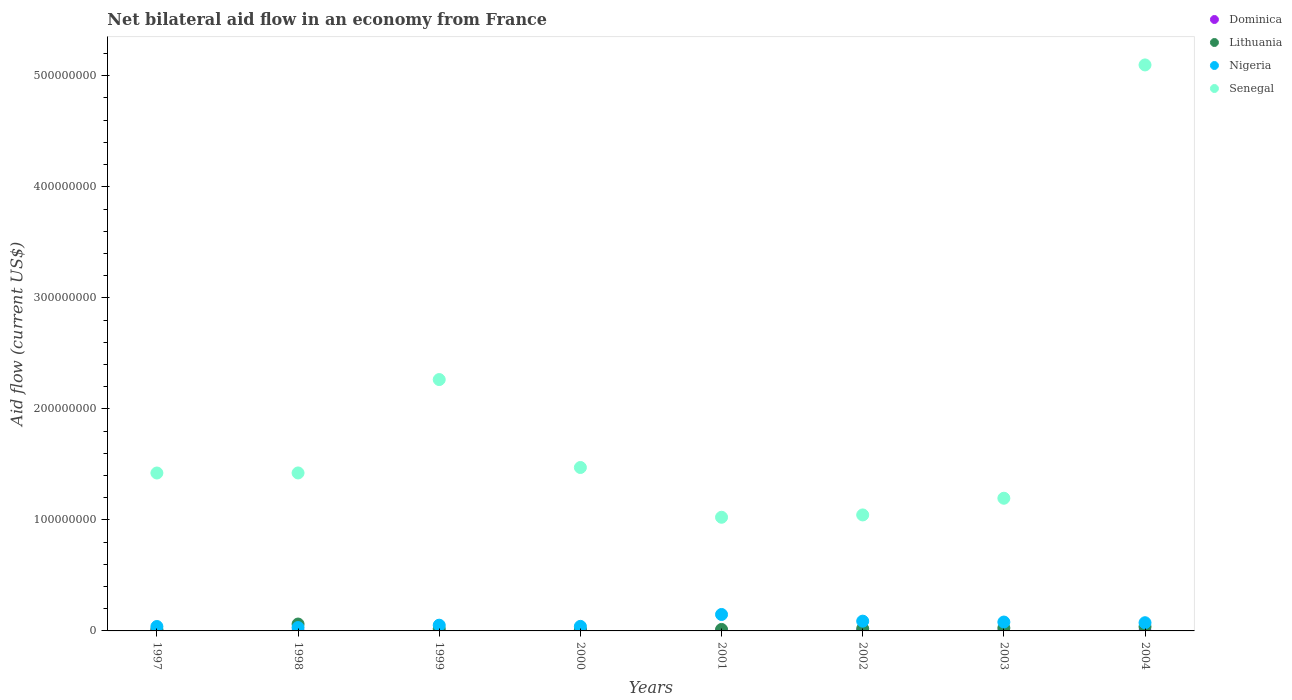What is the net bilateral aid flow in Nigeria in 1997?
Ensure brevity in your answer.  3.98e+06. Across all years, what is the maximum net bilateral aid flow in Nigeria?
Offer a very short reply. 1.48e+07. Across all years, what is the minimum net bilateral aid flow in Senegal?
Your response must be concise. 1.02e+08. In which year was the net bilateral aid flow in Senegal maximum?
Keep it short and to the point. 2004. What is the total net bilateral aid flow in Nigeria in the graph?
Ensure brevity in your answer.  5.52e+07. What is the difference between the net bilateral aid flow in Nigeria in 1999 and that in 2003?
Offer a terse response. -2.83e+06. What is the difference between the net bilateral aid flow in Nigeria in 2004 and the net bilateral aid flow in Senegal in 2002?
Give a very brief answer. -9.71e+07. What is the average net bilateral aid flow in Dominica per year?
Provide a succinct answer. 2.50e+04. In the year 2002, what is the difference between the net bilateral aid flow in Senegal and net bilateral aid flow in Nigeria?
Keep it short and to the point. 9.57e+07. In how many years, is the net bilateral aid flow in Dominica greater than 80000000 US$?
Make the answer very short. 0. What is the ratio of the net bilateral aid flow in Nigeria in 2002 to that in 2004?
Your answer should be very brief. 1.19. What is the difference between the highest and the second highest net bilateral aid flow in Senegal?
Make the answer very short. 2.83e+08. What is the difference between the highest and the lowest net bilateral aid flow in Senegal?
Your answer should be compact. 4.07e+08. In how many years, is the net bilateral aid flow in Senegal greater than the average net bilateral aid flow in Senegal taken over all years?
Provide a short and direct response. 2. Is the sum of the net bilateral aid flow in Lithuania in 2000 and 2001 greater than the maximum net bilateral aid flow in Senegal across all years?
Offer a very short reply. No. Does the net bilateral aid flow in Lithuania monotonically increase over the years?
Give a very brief answer. No. Is the net bilateral aid flow in Nigeria strictly greater than the net bilateral aid flow in Senegal over the years?
Your answer should be compact. No. Is the net bilateral aid flow in Senegal strictly less than the net bilateral aid flow in Nigeria over the years?
Provide a succinct answer. No. How many dotlines are there?
Keep it short and to the point. 4. Are the values on the major ticks of Y-axis written in scientific E-notation?
Your response must be concise. No. Does the graph contain grids?
Give a very brief answer. No. Where does the legend appear in the graph?
Provide a succinct answer. Top right. What is the title of the graph?
Offer a very short reply. Net bilateral aid flow in an economy from France. Does "Low income" appear as one of the legend labels in the graph?
Provide a succinct answer. No. What is the Aid flow (current US$) of Dominica in 1997?
Your answer should be very brief. 1.50e+05. What is the Aid flow (current US$) of Lithuania in 1997?
Your answer should be very brief. 1.29e+06. What is the Aid flow (current US$) in Nigeria in 1997?
Keep it short and to the point. 3.98e+06. What is the Aid flow (current US$) in Senegal in 1997?
Provide a succinct answer. 1.42e+08. What is the Aid flow (current US$) in Lithuania in 1998?
Make the answer very short. 6.20e+06. What is the Aid flow (current US$) of Nigeria in 1998?
Provide a short and direct response. 3.04e+06. What is the Aid flow (current US$) of Senegal in 1998?
Offer a terse response. 1.42e+08. What is the Aid flow (current US$) of Dominica in 1999?
Offer a terse response. 0. What is the Aid flow (current US$) in Lithuania in 1999?
Your response must be concise. 1.85e+06. What is the Aid flow (current US$) of Nigeria in 1999?
Your response must be concise. 5.16e+06. What is the Aid flow (current US$) in Senegal in 1999?
Keep it short and to the point. 2.26e+08. What is the Aid flow (current US$) in Lithuania in 2000?
Your response must be concise. 1.45e+06. What is the Aid flow (current US$) of Nigeria in 2000?
Keep it short and to the point. 4.10e+06. What is the Aid flow (current US$) in Senegal in 2000?
Make the answer very short. 1.47e+08. What is the Aid flow (current US$) of Dominica in 2001?
Offer a very short reply. 0. What is the Aid flow (current US$) in Lithuania in 2001?
Your answer should be compact. 1.34e+06. What is the Aid flow (current US$) of Nigeria in 2001?
Provide a short and direct response. 1.48e+07. What is the Aid flow (current US$) of Senegal in 2001?
Offer a very short reply. 1.02e+08. What is the Aid flow (current US$) in Lithuania in 2002?
Provide a succinct answer. 2.03e+06. What is the Aid flow (current US$) in Nigeria in 2002?
Provide a succinct answer. 8.79e+06. What is the Aid flow (current US$) in Senegal in 2002?
Provide a succinct answer. 1.04e+08. What is the Aid flow (current US$) of Dominica in 2003?
Give a very brief answer. 0. What is the Aid flow (current US$) of Lithuania in 2003?
Offer a terse response. 2.67e+06. What is the Aid flow (current US$) in Nigeria in 2003?
Provide a succinct answer. 7.99e+06. What is the Aid flow (current US$) in Senegal in 2003?
Make the answer very short. 1.20e+08. What is the Aid flow (current US$) in Dominica in 2004?
Offer a terse response. 0. What is the Aid flow (current US$) of Lithuania in 2004?
Your answer should be compact. 3.74e+06. What is the Aid flow (current US$) in Nigeria in 2004?
Offer a terse response. 7.38e+06. What is the Aid flow (current US$) in Senegal in 2004?
Ensure brevity in your answer.  5.10e+08. Across all years, what is the maximum Aid flow (current US$) in Dominica?
Offer a terse response. 1.50e+05. Across all years, what is the maximum Aid flow (current US$) of Lithuania?
Ensure brevity in your answer.  6.20e+06. Across all years, what is the maximum Aid flow (current US$) in Nigeria?
Keep it short and to the point. 1.48e+07. Across all years, what is the maximum Aid flow (current US$) of Senegal?
Offer a terse response. 5.10e+08. Across all years, what is the minimum Aid flow (current US$) in Dominica?
Keep it short and to the point. 0. Across all years, what is the minimum Aid flow (current US$) in Lithuania?
Provide a short and direct response. 1.29e+06. Across all years, what is the minimum Aid flow (current US$) of Nigeria?
Keep it short and to the point. 3.04e+06. Across all years, what is the minimum Aid flow (current US$) of Senegal?
Keep it short and to the point. 1.02e+08. What is the total Aid flow (current US$) of Lithuania in the graph?
Your response must be concise. 2.06e+07. What is the total Aid flow (current US$) of Nigeria in the graph?
Your response must be concise. 5.52e+07. What is the total Aid flow (current US$) in Senegal in the graph?
Offer a very short reply. 1.49e+09. What is the difference between the Aid flow (current US$) of Lithuania in 1997 and that in 1998?
Offer a very short reply. -4.91e+06. What is the difference between the Aid flow (current US$) in Nigeria in 1997 and that in 1998?
Your answer should be compact. 9.40e+05. What is the difference between the Aid flow (current US$) in Senegal in 1997 and that in 1998?
Offer a very short reply. -5.00e+04. What is the difference between the Aid flow (current US$) of Lithuania in 1997 and that in 1999?
Your answer should be compact. -5.60e+05. What is the difference between the Aid flow (current US$) in Nigeria in 1997 and that in 1999?
Make the answer very short. -1.18e+06. What is the difference between the Aid flow (current US$) in Senegal in 1997 and that in 1999?
Provide a short and direct response. -8.42e+07. What is the difference between the Aid flow (current US$) of Lithuania in 1997 and that in 2000?
Give a very brief answer. -1.60e+05. What is the difference between the Aid flow (current US$) of Nigeria in 1997 and that in 2000?
Your answer should be compact. -1.20e+05. What is the difference between the Aid flow (current US$) in Senegal in 1997 and that in 2000?
Provide a short and direct response. -4.96e+06. What is the difference between the Aid flow (current US$) in Nigeria in 1997 and that in 2001?
Your answer should be compact. -1.08e+07. What is the difference between the Aid flow (current US$) of Senegal in 1997 and that in 2001?
Make the answer very short. 3.99e+07. What is the difference between the Aid flow (current US$) of Lithuania in 1997 and that in 2002?
Offer a very short reply. -7.40e+05. What is the difference between the Aid flow (current US$) in Nigeria in 1997 and that in 2002?
Your answer should be compact. -4.81e+06. What is the difference between the Aid flow (current US$) in Senegal in 1997 and that in 2002?
Your response must be concise. 3.78e+07. What is the difference between the Aid flow (current US$) of Lithuania in 1997 and that in 2003?
Ensure brevity in your answer.  -1.38e+06. What is the difference between the Aid flow (current US$) of Nigeria in 1997 and that in 2003?
Ensure brevity in your answer.  -4.01e+06. What is the difference between the Aid flow (current US$) in Senegal in 1997 and that in 2003?
Offer a very short reply. 2.27e+07. What is the difference between the Aid flow (current US$) of Lithuania in 1997 and that in 2004?
Give a very brief answer. -2.45e+06. What is the difference between the Aid flow (current US$) in Nigeria in 1997 and that in 2004?
Your answer should be very brief. -3.40e+06. What is the difference between the Aid flow (current US$) in Senegal in 1997 and that in 2004?
Provide a succinct answer. -3.68e+08. What is the difference between the Aid flow (current US$) of Lithuania in 1998 and that in 1999?
Keep it short and to the point. 4.35e+06. What is the difference between the Aid flow (current US$) of Nigeria in 1998 and that in 1999?
Provide a succinct answer. -2.12e+06. What is the difference between the Aid flow (current US$) in Senegal in 1998 and that in 1999?
Your response must be concise. -8.41e+07. What is the difference between the Aid flow (current US$) in Lithuania in 1998 and that in 2000?
Your response must be concise. 4.75e+06. What is the difference between the Aid flow (current US$) in Nigeria in 1998 and that in 2000?
Offer a very short reply. -1.06e+06. What is the difference between the Aid flow (current US$) of Senegal in 1998 and that in 2000?
Provide a short and direct response. -4.91e+06. What is the difference between the Aid flow (current US$) in Lithuania in 1998 and that in 2001?
Ensure brevity in your answer.  4.86e+06. What is the difference between the Aid flow (current US$) of Nigeria in 1998 and that in 2001?
Your response must be concise. -1.18e+07. What is the difference between the Aid flow (current US$) in Senegal in 1998 and that in 2001?
Give a very brief answer. 3.99e+07. What is the difference between the Aid flow (current US$) of Lithuania in 1998 and that in 2002?
Make the answer very short. 4.17e+06. What is the difference between the Aid flow (current US$) of Nigeria in 1998 and that in 2002?
Your answer should be compact. -5.75e+06. What is the difference between the Aid flow (current US$) of Senegal in 1998 and that in 2002?
Your answer should be very brief. 3.78e+07. What is the difference between the Aid flow (current US$) of Lithuania in 1998 and that in 2003?
Keep it short and to the point. 3.53e+06. What is the difference between the Aid flow (current US$) of Nigeria in 1998 and that in 2003?
Offer a terse response. -4.95e+06. What is the difference between the Aid flow (current US$) in Senegal in 1998 and that in 2003?
Offer a terse response. 2.28e+07. What is the difference between the Aid flow (current US$) in Lithuania in 1998 and that in 2004?
Provide a short and direct response. 2.46e+06. What is the difference between the Aid flow (current US$) of Nigeria in 1998 and that in 2004?
Offer a terse response. -4.34e+06. What is the difference between the Aid flow (current US$) of Senegal in 1998 and that in 2004?
Your response must be concise. -3.67e+08. What is the difference between the Aid flow (current US$) of Nigeria in 1999 and that in 2000?
Give a very brief answer. 1.06e+06. What is the difference between the Aid flow (current US$) of Senegal in 1999 and that in 2000?
Your answer should be compact. 7.92e+07. What is the difference between the Aid flow (current US$) in Lithuania in 1999 and that in 2001?
Keep it short and to the point. 5.10e+05. What is the difference between the Aid flow (current US$) of Nigeria in 1999 and that in 2001?
Make the answer very short. -9.65e+06. What is the difference between the Aid flow (current US$) in Senegal in 1999 and that in 2001?
Your answer should be compact. 1.24e+08. What is the difference between the Aid flow (current US$) in Lithuania in 1999 and that in 2002?
Ensure brevity in your answer.  -1.80e+05. What is the difference between the Aid flow (current US$) in Nigeria in 1999 and that in 2002?
Your answer should be compact. -3.63e+06. What is the difference between the Aid flow (current US$) in Senegal in 1999 and that in 2002?
Provide a short and direct response. 1.22e+08. What is the difference between the Aid flow (current US$) in Lithuania in 1999 and that in 2003?
Offer a terse response. -8.20e+05. What is the difference between the Aid flow (current US$) in Nigeria in 1999 and that in 2003?
Keep it short and to the point. -2.83e+06. What is the difference between the Aid flow (current US$) of Senegal in 1999 and that in 2003?
Your answer should be very brief. 1.07e+08. What is the difference between the Aid flow (current US$) of Lithuania in 1999 and that in 2004?
Offer a terse response. -1.89e+06. What is the difference between the Aid flow (current US$) in Nigeria in 1999 and that in 2004?
Your answer should be very brief. -2.22e+06. What is the difference between the Aid flow (current US$) of Senegal in 1999 and that in 2004?
Your answer should be very brief. -2.83e+08. What is the difference between the Aid flow (current US$) in Lithuania in 2000 and that in 2001?
Keep it short and to the point. 1.10e+05. What is the difference between the Aid flow (current US$) of Nigeria in 2000 and that in 2001?
Your response must be concise. -1.07e+07. What is the difference between the Aid flow (current US$) of Senegal in 2000 and that in 2001?
Ensure brevity in your answer.  4.48e+07. What is the difference between the Aid flow (current US$) of Lithuania in 2000 and that in 2002?
Provide a short and direct response. -5.80e+05. What is the difference between the Aid flow (current US$) in Nigeria in 2000 and that in 2002?
Give a very brief answer. -4.69e+06. What is the difference between the Aid flow (current US$) of Senegal in 2000 and that in 2002?
Your response must be concise. 4.27e+07. What is the difference between the Aid flow (current US$) in Lithuania in 2000 and that in 2003?
Give a very brief answer. -1.22e+06. What is the difference between the Aid flow (current US$) of Nigeria in 2000 and that in 2003?
Your answer should be very brief. -3.89e+06. What is the difference between the Aid flow (current US$) of Senegal in 2000 and that in 2003?
Keep it short and to the point. 2.77e+07. What is the difference between the Aid flow (current US$) of Lithuania in 2000 and that in 2004?
Your answer should be very brief. -2.29e+06. What is the difference between the Aid flow (current US$) of Nigeria in 2000 and that in 2004?
Provide a short and direct response. -3.28e+06. What is the difference between the Aid flow (current US$) of Senegal in 2000 and that in 2004?
Your answer should be compact. -3.63e+08. What is the difference between the Aid flow (current US$) in Lithuania in 2001 and that in 2002?
Offer a terse response. -6.90e+05. What is the difference between the Aid flow (current US$) of Nigeria in 2001 and that in 2002?
Give a very brief answer. 6.02e+06. What is the difference between the Aid flow (current US$) in Senegal in 2001 and that in 2002?
Provide a succinct answer. -2.10e+06. What is the difference between the Aid flow (current US$) of Lithuania in 2001 and that in 2003?
Keep it short and to the point. -1.33e+06. What is the difference between the Aid flow (current US$) of Nigeria in 2001 and that in 2003?
Make the answer very short. 6.82e+06. What is the difference between the Aid flow (current US$) in Senegal in 2001 and that in 2003?
Offer a very short reply. -1.71e+07. What is the difference between the Aid flow (current US$) in Lithuania in 2001 and that in 2004?
Your answer should be very brief. -2.40e+06. What is the difference between the Aid flow (current US$) of Nigeria in 2001 and that in 2004?
Your answer should be compact. 7.43e+06. What is the difference between the Aid flow (current US$) of Senegal in 2001 and that in 2004?
Provide a succinct answer. -4.07e+08. What is the difference between the Aid flow (current US$) of Lithuania in 2002 and that in 2003?
Your answer should be compact. -6.40e+05. What is the difference between the Aid flow (current US$) in Nigeria in 2002 and that in 2003?
Give a very brief answer. 8.00e+05. What is the difference between the Aid flow (current US$) of Senegal in 2002 and that in 2003?
Provide a succinct answer. -1.50e+07. What is the difference between the Aid flow (current US$) in Lithuania in 2002 and that in 2004?
Provide a succinct answer. -1.71e+06. What is the difference between the Aid flow (current US$) in Nigeria in 2002 and that in 2004?
Your response must be concise. 1.41e+06. What is the difference between the Aid flow (current US$) of Senegal in 2002 and that in 2004?
Provide a succinct answer. -4.05e+08. What is the difference between the Aid flow (current US$) of Lithuania in 2003 and that in 2004?
Give a very brief answer. -1.07e+06. What is the difference between the Aid flow (current US$) of Nigeria in 2003 and that in 2004?
Offer a terse response. 6.10e+05. What is the difference between the Aid flow (current US$) in Senegal in 2003 and that in 2004?
Provide a succinct answer. -3.90e+08. What is the difference between the Aid flow (current US$) of Dominica in 1997 and the Aid flow (current US$) of Lithuania in 1998?
Provide a succinct answer. -6.05e+06. What is the difference between the Aid flow (current US$) of Dominica in 1997 and the Aid flow (current US$) of Nigeria in 1998?
Give a very brief answer. -2.89e+06. What is the difference between the Aid flow (current US$) in Dominica in 1997 and the Aid flow (current US$) in Senegal in 1998?
Provide a succinct answer. -1.42e+08. What is the difference between the Aid flow (current US$) in Lithuania in 1997 and the Aid flow (current US$) in Nigeria in 1998?
Provide a short and direct response. -1.75e+06. What is the difference between the Aid flow (current US$) of Lithuania in 1997 and the Aid flow (current US$) of Senegal in 1998?
Give a very brief answer. -1.41e+08. What is the difference between the Aid flow (current US$) of Nigeria in 1997 and the Aid flow (current US$) of Senegal in 1998?
Ensure brevity in your answer.  -1.38e+08. What is the difference between the Aid flow (current US$) in Dominica in 1997 and the Aid flow (current US$) in Lithuania in 1999?
Provide a short and direct response. -1.70e+06. What is the difference between the Aid flow (current US$) of Dominica in 1997 and the Aid flow (current US$) of Nigeria in 1999?
Your answer should be very brief. -5.01e+06. What is the difference between the Aid flow (current US$) of Dominica in 1997 and the Aid flow (current US$) of Senegal in 1999?
Offer a very short reply. -2.26e+08. What is the difference between the Aid flow (current US$) in Lithuania in 1997 and the Aid flow (current US$) in Nigeria in 1999?
Offer a very short reply. -3.87e+06. What is the difference between the Aid flow (current US$) of Lithuania in 1997 and the Aid flow (current US$) of Senegal in 1999?
Offer a very short reply. -2.25e+08. What is the difference between the Aid flow (current US$) of Nigeria in 1997 and the Aid flow (current US$) of Senegal in 1999?
Provide a short and direct response. -2.22e+08. What is the difference between the Aid flow (current US$) in Dominica in 1997 and the Aid flow (current US$) in Lithuania in 2000?
Make the answer very short. -1.30e+06. What is the difference between the Aid flow (current US$) in Dominica in 1997 and the Aid flow (current US$) in Nigeria in 2000?
Give a very brief answer. -3.95e+06. What is the difference between the Aid flow (current US$) in Dominica in 1997 and the Aid flow (current US$) in Senegal in 2000?
Your answer should be compact. -1.47e+08. What is the difference between the Aid flow (current US$) of Lithuania in 1997 and the Aid flow (current US$) of Nigeria in 2000?
Give a very brief answer. -2.81e+06. What is the difference between the Aid flow (current US$) in Lithuania in 1997 and the Aid flow (current US$) in Senegal in 2000?
Your response must be concise. -1.46e+08. What is the difference between the Aid flow (current US$) of Nigeria in 1997 and the Aid flow (current US$) of Senegal in 2000?
Make the answer very short. -1.43e+08. What is the difference between the Aid flow (current US$) of Dominica in 1997 and the Aid flow (current US$) of Lithuania in 2001?
Provide a short and direct response. -1.19e+06. What is the difference between the Aid flow (current US$) in Dominica in 1997 and the Aid flow (current US$) in Nigeria in 2001?
Provide a short and direct response. -1.47e+07. What is the difference between the Aid flow (current US$) in Dominica in 1997 and the Aid flow (current US$) in Senegal in 2001?
Make the answer very short. -1.02e+08. What is the difference between the Aid flow (current US$) in Lithuania in 1997 and the Aid flow (current US$) in Nigeria in 2001?
Provide a short and direct response. -1.35e+07. What is the difference between the Aid flow (current US$) in Lithuania in 1997 and the Aid flow (current US$) in Senegal in 2001?
Provide a short and direct response. -1.01e+08. What is the difference between the Aid flow (current US$) in Nigeria in 1997 and the Aid flow (current US$) in Senegal in 2001?
Provide a succinct answer. -9.84e+07. What is the difference between the Aid flow (current US$) in Dominica in 1997 and the Aid flow (current US$) in Lithuania in 2002?
Make the answer very short. -1.88e+06. What is the difference between the Aid flow (current US$) of Dominica in 1997 and the Aid flow (current US$) of Nigeria in 2002?
Make the answer very short. -8.64e+06. What is the difference between the Aid flow (current US$) in Dominica in 1997 and the Aid flow (current US$) in Senegal in 2002?
Keep it short and to the point. -1.04e+08. What is the difference between the Aid flow (current US$) of Lithuania in 1997 and the Aid flow (current US$) of Nigeria in 2002?
Provide a succinct answer. -7.50e+06. What is the difference between the Aid flow (current US$) in Lithuania in 1997 and the Aid flow (current US$) in Senegal in 2002?
Your answer should be very brief. -1.03e+08. What is the difference between the Aid flow (current US$) of Nigeria in 1997 and the Aid flow (current US$) of Senegal in 2002?
Offer a terse response. -1.00e+08. What is the difference between the Aid flow (current US$) in Dominica in 1997 and the Aid flow (current US$) in Lithuania in 2003?
Ensure brevity in your answer.  -2.52e+06. What is the difference between the Aid flow (current US$) in Dominica in 1997 and the Aid flow (current US$) in Nigeria in 2003?
Your answer should be very brief. -7.84e+06. What is the difference between the Aid flow (current US$) in Dominica in 1997 and the Aid flow (current US$) in Senegal in 2003?
Your answer should be very brief. -1.19e+08. What is the difference between the Aid flow (current US$) in Lithuania in 1997 and the Aid flow (current US$) in Nigeria in 2003?
Offer a very short reply. -6.70e+06. What is the difference between the Aid flow (current US$) in Lithuania in 1997 and the Aid flow (current US$) in Senegal in 2003?
Give a very brief answer. -1.18e+08. What is the difference between the Aid flow (current US$) in Nigeria in 1997 and the Aid flow (current US$) in Senegal in 2003?
Give a very brief answer. -1.16e+08. What is the difference between the Aid flow (current US$) in Dominica in 1997 and the Aid flow (current US$) in Lithuania in 2004?
Your answer should be compact. -3.59e+06. What is the difference between the Aid flow (current US$) in Dominica in 1997 and the Aid flow (current US$) in Nigeria in 2004?
Make the answer very short. -7.23e+06. What is the difference between the Aid flow (current US$) of Dominica in 1997 and the Aid flow (current US$) of Senegal in 2004?
Give a very brief answer. -5.10e+08. What is the difference between the Aid flow (current US$) of Lithuania in 1997 and the Aid flow (current US$) of Nigeria in 2004?
Offer a terse response. -6.09e+06. What is the difference between the Aid flow (current US$) in Lithuania in 1997 and the Aid flow (current US$) in Senegal in 2004?
Your response must be concise. -5.08e+08. What is the difference between the Aid flow (current US$) in Nigeria in 1997 and the Aid flow (current US$) in Senegal in 2004?
Keep it short and to the point. -5.06e+08. What is the difference between the Aid flow (current US$) of Lithuania in 1998 and the Aid flow (current US$) of Nigeria in 1999?
Your answer should be compact. 1.04e+06. What is the difference between the Aid flow (current US$) of Lithuania in 1998 and the Aid flow (current US$) of Senegal in 1999?
Offer a terse response. -2.20e+08. What is the difference between the Aid flow (current US$) of Nigeria in 1998 and the Aid flow (current US$) of Senegal in 1999?
Keep it short and to the point. -2.23e+08. What is the difference between the Aid flow (current US$) of Lithuania in 1998 and the Aid flow (current US$) of Nigeria in 2000?
Offer a terse response. 2.10e+06. What is the difference between the Aid flow (current US$) of Lithuania in 1998 and the Aid flow (current US$) of Senegal in 2000?
Your response must be concise. -1.41e+08. What is the difference between the Aid flow (current US$) of Nigeria in 1998 and the Aid flow (current US$) of Senegal in 2000?
Ensure brevity in your answer.  -1.44e+08. What is the difference between the Aid flow (current US$) in Lithuania in 1998 and the Aid flow (current US$) in Nigeria in 2001?
Ensure brevity in your answer.  -8.61e+06. What is the difference between the Aid flow (current US$) in Lithuania in 1998 and the Aid flow (current US$) in Senegal in 2001?
Your answer should be very brief. -9.62e+07. What is the difference between the Aid flow (current US$) of Nigeria in 1998 and the Aid flow (current US$) of Senegal in 2001?
Ensure brevity in your answer.  -9.93e+07. What is the difference between the Aid flow (current US$) in Lithuania in 1998 and the Aid flow (current US$) in Nigeria in 2002?
Provide a succinct answer. -2.59e+06. What is the difference between the Aid flow (current US$) of Lithuania in 1998 and the Aid flow (current US$) of Senegal in 2002?
Provide a succinct answer. -9.83e+07. What is the difference between the Aid flow (current US$) of Nigeria in 1998 and the Aid flow (current US$) of Senegal in 2002?
Your answer should be very brief. -1.01e+08. What is the difference between the Aid flow (current US$) in Lithuania in 1998 and the Aid flow (current US$) in Nigeria in 2003?
Your answer should be very brief. -1.79e+06. What is the difference between the Aid flow (current US$) of Lithuania in 1998 and the Aid flow (current US$) of Senegal in 2003?
Ensure brevity in your answer.  -1.13e+08. What is the difference between the Aid flow (current US$) in Nigeria in 1998 and the Aid flow (current US$) in Senegal in 2003?
Make the answer very short. -1.16e+08. What is the difference between the Aid flow (current US$) in Lithuania in 1998 and the Aid flow (current US$) in Nigeria in 2004?
Offer a very short reply. -1.18e+06. What is the difference between the Aid flow (current US$) of Lithuania in 1998 and the Aid flow (current US$) of Senegal in 2004?
Ensure brevity in your answer.  -5.04e+08. What is the difference between the Aid flow (current US$) in Nigeria in 1998 and the Aid flow (current US$) in Senegal in 2004?
Give a very brief answer. -5.07e+08. What is the difference between the Aid flow (current US$) of Lithuania in 1999 and the Aid flow (current US$) of Nigeria in 2000?
Give a very brief answer. -2.25e+06. What is the difference between the Aid flow (current US$) of Lithuania in 1999 and the Aid flow (current US$) of Senegal in 2000?
Ensure brevity in your answer.  -1.45e+08. What is the difference between the Aid flow (current US$) of Nigeria in 1999 and the Aid flow (current US$) of Senegal in 2000?
Make the answer very short. -1.42e+08. What is the difference between the Aid flow (current US$) in Lithuania in 1999 and the Aid flow (current US$) in Nigeria in 2001?
Offer a terse response. -1.30e+07. What is the difference between the Aid flow (current US$) of Lithuania in 1999 and the Aid flow (current US$) of Senegal in 2001?
Your response must be concise. -1.01e+08. What is the difference between the Aid flow (current US$) in Nigeria in 1999 and the Aid flow (current US$) in Senegal in 2001?
Ensure brevity in your answer.  -9.72e+07. What is the difference between the Aid flow (current US$) in Lithuania in 1999 and the Aid flow (current US$) in Nigeria in 2002?
Keep it short and to the point. -6.94e+06. What is the difference between the Aid flow (current US$) of Lithuania in 1999 and the Aid flow (current US$) of Senegal in 2002?
Your answer should be very brief. -1.03e+08. What is the difference between the Aid flow (current US$) in Nigeria in 1999 and the Aid flow (current US$) in Senegal in 2002?
Your answer should be compact. -9.93e+07. What is the difference between the Aid flow (current US$) in Lithuania in 1999 and the Aid flow (current US$) in Nigeria in 2003?
Provide a succinct answer. -6.14e+06. What is the difference between the Aid flow (current US$) in Lithuania in 1999 and the Aid flow (current US$) in Senegal in 2003?
Keep it short and to the point. -1.18e+08. What is the difference between the Aid flow (current US$) in Nigeria in 1999 and the Aid flow (current US$) in Senegal in 2003?
Provide a succinct answer. -1.14e+08. What is the difference between the Aid flow (current US$) in Lithuania in 1999 and the Aid flow (current US$) in Nigeria in 2004?
Make the answer very short. -5.53e+06. What is the difference between the Aid flow (current US$) of Lithuania in 1999 and the Aid flow (current US$) of Senegal in 2004?
Ensure brevity in your answer.  -5.08e+08. What is the difference between the Aid flow (current US$) of Nigeria in 1999 and the Aid flow (current US$) of Senegal in 2004?
Your answer should be very brief. -5.05e+08. What is the difference between the Aid flow (current US$) of Dominica in 2000 and the Aid flow (current US$) of Lithuania in 2001?
Offer a terse response. -1.31e+06. What is the difference between the Aid flow (current US$) of Dominica in 2000 and the Aid flow (current US$) of Nigeria in 2001?
Keep it short and to the point. -1.48e+07. What is the difference between the Aid flow (current US$) of Dominica in 2000 and the Aid flow (current US$) of Senegal in 2001?
Offer a terse response. -1.02e+08. What is the difference between the Aid flow (current US$) in Lithuania in 2000 and the Aid flow (current US$) in Nigeria in 2001?
Keep it short and to the point. -1.34e+07. What is the difference between the Aid flow (current US$) of Lithuania in 2000 and the Aid flow (current US$) of Senegal in 2001?
Your response must be concise. -1.01e+08. What is the difference between the Aid flow (current US$) of Nigeria in 2000 and the Aid flow (current US$) of Senegal in 2001?
Offer a very short reply. -9.83e+07. What is the difference between the Aid flow (current US$) in Dominica in 2000 and the Aid flow (current US$) in Nigeria in 2002?
Offer a very short reply. -8.76e+06. What is the difference between the Aid flow (current US$) of Dominica in 2000 and the Aid flow (current US$) of Senegal in 2002?
Give a very brief answer. -1.04e+08. What is the difference between the Aid flow (current US$) in Lithuania in 2000 and the Aid flow (current US$) in Nigeria in 2002?
Provide a short and direct response. -7.34e+06. What is the difference between the Aid flow (current US$) of Lithuania in 2000 and the Aid flow (current US$) of Senegal in 2002?
Offer a very short reply. -1.03e+08. What is the difference between the Aid flow (current US$) in Nigeria in 2000 and the Aid flow (current US$) in Senegal in 2002?
Provide a short and direct response. -1.00e+08. What is the difference between the Aid flow (current US$) in Dominica in 2000 and the Aid flow (current US$) in Lithuania in 2003?
Your answer should be compact. -2.64e+06. What is the difference between the Aid flow (current US$) of Dominica in 2000 and the Aid flow (current US$) of Nigeria in 2003?
Offer a very short reply. -7.96e+06. What is the difference between the Aid flow (current US$) of Dominica in 2000 and the Aid flow (current US$) of Senegal in 2003?
Provide a short and direct response. -1.19e+08. What is the difference between the Aid flow (current US$) in Lithuania in 2000 and the Aid flow (current US$) in Nigeria in 2003?
Provide a short and direct response. -6.54e+06. What is the difference between the Aid flow (current US$) of Lithuania in 2000 and the Aid flow (current US$) of Senegal in 2003?
Give a very brief answer. -1.18e+08. What is the difference between the Aid flow (current US$) in Nigeria in 2000 and the Aid flow (current US$) in Senegal in 2003?
Provide a short and direct response. -1.15e+08. What is the difference between the Aid flow (current US$) of Dominica in 2000 and the Aid flow (current US$) of Lithuania in 2004?
Your answer should be very brief. -3.71e+06. What is the difference between the Aid flow (current US$) of Dominica in 2000 and the Aid flow (current US$) of Nigeria in 2004?
Give a very brief answer. -7.35e+06. What is the difference between the Aid flow (current US$) in Dominica in 2000 and the Aid flow (current US$) in Senegal in 2004?
Your answer should be very brief. -5.10e+08. What is the difference between the Aid flow (current US$) in Lithuania in 2000 and the Aid flow (current US$) in Nigeria in 2004?
Ensure brevity in your answer.  -5.93e+06. What is the difference between the Aid flow (current US$) in Lithuania in 2000 and the Aid flow (current US$) in Senegal in 2004?
Make the answer very short. -5.08e+08. What is the difference between the Aid flow (current US$) of Nigeria in 2000 and the Aid flow (current US$) of Senegal in 2004?
Offer a very short reply. -5.06e+08. What is the difference between the Aid flow (current US$) in Lithuania in 2001 and the Aid flow (current US$) in Nigeria in 2002?
Provide a succinct answer. -7.45e+06. What is the difference between the Aid flow (current US$) of Lithuania in 2001 and the Aid flow (current US$) of Senegal in 2002?
Your answer should be very brief. -1.03e+08. What is the difference between the Aid flow (current US$) of Nigeria in 2001 and the Aid flow (current US$) of Senegal in 2002?
Keep it short and to the point. -8.97e+07. What is the difference between the Aid flow (current US$) of Lithuania in 2001 and the Aid flow (current US$) of Nigeria in 2003?
Ensure brevity in your answer.  -6.65e+06. What is the difference between the Aid flow (current US$) in Lithuania in 2001 and the Aid flow (current US$) in Senegal in 2003?
Keep it short and to the point. -1.18e+08. What is the difference between the Aid flow (current US$) in Nigeria in 2001 and the Aid flow (current US$) in Senegal in 2003?
Your answer should be very brief. -1.05e+08. What is the difference between the Aid flow (current US$) of Lithuania in 2001 and the Aid flow (current US$) of Nigeria in 2004?
Your response must be concise. -6.04e+06. What is the difference between the Aid flow (current US$) of Lithuania in 2001 and the Aid flow (current US$) of Senegal in 2004?
Provide a succinct answer. -5.08e+08. What is the difference between the Aid flow (current US$) in Nigeria in 2001 and the Aid flow (current US$) in Senegal in 2004?
Your answer should be very brief. -4.95e+08. What is the difference between the Aid flow (current US$) in Dominica in 2002 and the Aid flow (current US$) in Lithuania in 2003?
Offer a terse response. -2.65e+06. What is the difference between the Aid flow (current US$) in Dominica in 2002 and the Aid flow (current US$) in Nigeria in 2003?
Your answer should be very brief. -7.97e+06. What is the difference between the Aid flow (current US$) of Dominica in 2002 and the Aid flow (current US$) of Senegal in 2003?
Make the answer very short. -1.19e+08. What is the difference between the Aid flow (current US$) of Lithuania in 2002 and the Aid flow (current US$) of Nigeria in 2003?
Give a very brief answer. -5.96e+06. What is the difference between the Aid flow (current US$) of Lithuania in 2002 and the Aid flow (current US$) of Senegal in 2003?
Make the answer very short. -1.17e+08. What is the difference between the Aid flow (current US$) in Nigeria in 2002 and the Aid flow (current US$) in Senegal in 2003?
Give a very brief answer. -1.11e+08. What is the difference between the Aid flow (current US$) in Dominica in 2002 and the Aid flow (current US$) in Lithuania in 2004?
Your answer should be compact. -3.72e+06. What is the difference between the Aid flow (current US$) of Dominica in 2002 and the Aid flow (current US$) of Nigeria in 2004?
Make the answer very short. -7.36e+06. What is the difference between the Aid flow (current US$) of Dominica in 2002 and the Aid flow (current US$) of Senegal in 2004?
Make the answer very short. -5.10e+08. What is the difference between the Aid flow (current US$) in Lithuania in 2002 and the Aid flow (current US$) in Nigeria in 2004?
Give a very brief answer. -5.35e+06. What is the difference between the Aid flow (current US$) of Lithuania in 2002 and the Aid flow (current US$) of Senegal in 2004?
Give a very brief answer. -5.08e+08. What is the difference between the Aid flow (current US$) in Nigeria in 2002 and the Aid flow (current US$) in Senegal in 2004?
Keep it short and to the point. -5.01e+08. What is the difference between the Aid flow (current US$) in Lithuania in 2003 and the Aid flow (current US$) in Nigeria in 2004?
Your answer should be compact. -4.71e+06. What is the difference between the Aid flow (current US$) in Lithuania in 2003 and the Aid flow (current US$) in Senegal in 2004?
Provide a short and direct response. -5.07e+08. What is the difference between the Aid flow (current US$) in Nigeria in 2003 and the Aid flow (current US$) in Senegal in 2004?
Offer a very short reply. -5.02e+08. What is the average Aid flow (current US$) in Dominica per year?
Ensure brevity in your answer.  2.50e+04. What is the average Aid flow (current US$) in Lithuania per year?
Offer a terse response. 2.57e+06. What is the average Aid flow (current US$) in Nigeria per year?
Provide a succinct answer. 6.91e+06. What is the average Aid flow (current US$) of Senegal per year?
Ensure brevity in your answer.  1.87e+08. In the year 1997, what is the difference between the Aid flow (current US$) in Dominica and Aid flow (current US$) in Lithuania?
Keep it short and to the point. -1.14e+06. In the year 1997, what is the difference between the Aid flow (current US$) of Dominica and Aid flow (current US$) of Nigeria?
Provide a short and direct response. -3.83e+06. In the year 1997, what is the difference between the Aid flow (current US$) in Dominica and Aid flow (current US$) in Senegal?
Your answer should be compact. -1.42e+08. In the year 1997, what is the difference between the Aid flow (current US$) of Lithuania and Aid flow (current US$) of Nigeria?
Make the answer very short. -2.69e+06. In the year 1997, what is the difference between the Aid flow (current US$) in Lithuania and Aid flow (current US$) in Senegal?
Offer a terse response. -1.41e+08. In the year 1997, what is the difference between the Aid flow (current US$) in Nigeria and Aid flow (current US$) in Senegal?
Your answer should be very brief. -1.38e+08. In the year 1998, what is the difference between the Aid flow (current US$) of Lithuania and Aid flow (current US$) of Nigeria?
Ensure brevity in your answer.  3.16e+06. In the year 1998, what is the difference between the Aid flow (current US$) of Lithuania and Aid flow (current US$) of Senegal?
Provide a succinct answer. -1.36e+08. In the year 1998, what is the difference between the Aid flow (current US$) in Nigeria and Aid flow (current US$) in Senegal?
Your response must be concise. -1.39e+08. In the year 1999, what is the difference between the Aid flow (current US$) in Lithuania and Aid flow (current US$) in Nigeria?
Keep it short and to the point. -3.31e+06. In the year 1999, what is the difference between the Aid flow (current US$) of Lithuania and Aid flow (current US$) of Senegal?
Offer a very short reply. -2.25e+08. In the year 1999, what is the difference between the Aid flow (current US$) of Nigeria and Aid flow (current US$) of Senegal?
Provide a short and direct response. -2.21e+08. In the year 2000, what is the difference between the Aid flow (current US$) in Dominica and Aid flow (current US$) in Lithuania?
Your answer should be compact. -1.42e+06. In the year 2000, what is the difference between the Aid flow (current US$) of Dominica and Aid flow (current US$) of Nigeria?
Keep it short and to the point. -4.07e+06. In the year 2000, what is the difference between the Aid flow (current US$) in Dominica and Aid flow (current US$) in Senegal?
Offer a very short reply. -1.47e+08. In the year 2000, what is the difference between the Aid flow (current US$) of Lithuania and Aid flow (current US$) of Nigeria?
Make the answer very short. -2.65e+06. In the year 2000, what is the difference between the Aid flow (current US$) in Lithuania and Aid flow (current US$) in Senegal?
Keep it short and to the point. -1.46e+08. In the year 2000, what is the difference between the Aid flow (current US$) of Nigeria and Aid flow (current US$) of Senegal?
Keep it short and to the point. -1.43e+08. In the year 2001, what is the difference between the Aid flow (current US$) of Lithuania and Aid flow (current US$) of Nigeria?
Offer a terse response. -1.35e+07. In the year 2001, what is the difference between the Aid flow (current US$) in Lithuania and Aid flow (current US$) in Senegal?
Provide a short and direct response. -1.01e+08. In the year 2001, what is the difference between the Aid flow (current US$) of Nigeria and Aid flow (current US$) of Senegal?
Keep it short and to the point. -8.76e+07. In the year 2002, what is the difference between the Aid flow (current US$) of Dominica and Aid flow (current US$) of Lithuania?
Offer a very short reply. -2.01e+06. In the year 2002, what is the difference between the Aid flow (current US$) of Dominica and Aid flow (current US$) of Nigeria?
Provide a short and direct response. -8.77e+06. In the year 2002, what is the difference between the Aid flow (current US$) of Dominica and Aid flow (current US$) of Senegal?
Your response must be concise. -1.04e+08. In the year 2002, what is the difference between the Aid flow (current US$) in Lithuania and Aid flow (current US$) in Nigeria?
Your response must be concise. -6.76e+06. In the year 2002, what is the difference between the Aid flow (current US$) in Lithuania and Aid flow (current US$) in Senegal?
Your answer should be very brief. -1.02e+08. In the year 2002, what is the difference between the Aid flow (current US$) in Nigeria and Aid flow (current US$) in Senegal?
Give a very brief answer. -9.57e+07. In the year 2003, what is the difference between the Aid flow (current US$) of Lithuania and Aid flow (current US$) of Nigeria?
Give a very brief answer. -5.32e+06. In the year 2003, what is the difference between the Aid flow (current US$) of Lithuania and Aid flow (current US$) of Senegal?
Your answer should be very brief. -1.17e+08. In the year 2003, what is the difference between the Aid flow (current US$) of Nigeria and Aid flow (current US$) of Senegal?
Offer a terse response. -1.12e+08. In the year 2004, what is the difference between the Aid flow (current US$) of Lithuania and Aid flow (current US$) of Nigeria?
Keep it short and to the point. -3.64e+06. In the year 2004, what is the difference between the Aid flow (current US$) of Lithuania and Aid flow (current US$) of Senegal?
Ensure brevity in your answer.  -5.06e+08. In the year 2004, what is the difference between the Aid flow (current US$) in Nigeria and Aid flow (current US$) in Senegal?
Offer a terse response. -5.02e+08. What is the ratio of the Aid flow (current US$) in Lithuania in 1997 to that in 1998?
Keep it short and to the point. 0.21. What is the ratio of the Aid flow (current US$) in Nigeria in 1997 to that in 1998?
Offer a very short reply. 1.31. What is the ratio of the Aid flow (current US$) in Senegal in 1997 to that in 1998?
Ensure brevity in your answer.  1. What is the ratio of the Aid flow (current US$) in Lithuania in 1997 to that in 1999?
Your answer should be compact. 0.7. What is the ratio of the Aid flow (current US$) in Nigeria in 1997 to that in 1999?
Your response must be concise. 0.77. What is the ratio of the Aid flow (current US$) of Senegal in 1997 to that in 1999?
Your answer should be very brief. 0.63. What is the ratio of the Aid flow (current US$) in Lithuania in 1997 to that in 2000?
Your answer should be very brief. 0.89. What is the ratio of the Aid flow (current US$) of Nigeria in 1997 to that in 2000?
Keep it short and to the point. 0.97. What is the ratio of the Aid flow (current US$) of Senegal in 1997 to that in 2000?
Your answer should be compact. 0.97. What is the ratio of the Aid flow (current US$) in Lithuania in 1997 to that in 2001?
Your response must be concise. 0.96. What is the ratio of the Aid flow (current US$) of Nigeria in 1997 to that in 2001?
Provide a short and direct response. 0.27. What is the ratio of the Aid flow (current US$) in Senegal in 1997 to that in 2001?
Give a very brief answer. 1.39. What is the ratio of the Aid flow (current US$) in Dominica in 1997 to that in 2002?
Provide a succinct answer. 7.5. What is the ratio of the Aid flow (current US$) in Lithuania in 1997 to that in 2002?
Provide a succinct answer. 0.64. What is the ratio of the Aid flow (current US$) in Nigeria in 1997 to that in 2002?
Ensure brevity in your answer.  0.45. What is the ratio of the Aid flow (current US$) of Senegal in 1997 to that in 2002?
Your answer should be very brief. 1.36. What is the ratio of the Aid flow (current US$) of Lithuania in 1997 to that in 2003?
Keep it short and to the point. 0.48. What is the ratio of the Aid flow (current US$) of Nigeria in 1997 to that in 2003?
Your answer should be very brief. 0.5. What is the ratio of the Aid flow (current US$) of Senegal in 1997 to that in 2003?
Your response must be concise. 1.19. What is the ratio of the Aid flow (current US$) in Lithuania in 1997 to that in 2004?
Give a very brief answer. 0.34. What is the ratio of the Aid flow (current US$) in Nigeria in 1997 to that in 2004?
Provide a succinct answer. 0.54. What is the ratio of the Aid flow (current US$) in Senegal in 1997 to that in 2004?
Your answer should be very brief. 0.28. What is the ratio of the Aid flow (current US$) of Lithuania in 1998 to that in 1999?
Your response must be concise. 3.35. What is the ratio of the Aid flow (current US$) of Nigeria in 1998 to that in 1999?
Keep it short and to the point. 0.59. What is the ratio of the Aid flow (current US$) in Senegal in 1998 to that in 1999?
Provide a short and direct response. 0.63. What is the ratio of the Aid flow (current US$) of Lithuania in 1998 to that in 2000?
Provide a succinct answer. 4.28. What is the ratio of the Aid flow (current US$) in Nigeria in 1998 to that in 2000?
Ensure brevity in your answer.  0.74. What is the ratio of the Aid flow (current US$) in Senegal in 1998 to that in 2000?
Offer a terse response. 0.97. What is the ratio of the Aid flow (current US$) in Lithuania in 1998 to that in 2001?
Provide a succinct answer. 4.63. What is the ratio of the Aid flow (current US$) in Nigeria in 1998 to that in 2001?
Make the answer very short. 0.21. What is the ratio of the Aid flow (current US$) of Senegal in 1998 to that in 2001?
Your response must be concise. 1.39. What is the ratio of the Aid flow (current US$) in Lithuania in 1998 to that in 2002?
Make the answer very short. 3.05. What is the ratio of the Aid flow (current US$) in Nigeria in 1998 to that in 2002?
Give a very brief answer. 0.35. What is the ratio of the Aid flow (current US$) in Senegal in 1998 to that in 2002?
Offer a terse response. 1.36. What is the ratio of the Aid flow (current US$) in Lithuania in 1998 to that in 2003?
Your answer should be very brief. 2.32. What is the ratio of the Aid flow (current US$) of Nigeria in 1998 to that in 2003?
Offer a very short reply. 0.38. What is the ratio of the Aid flow (current US$) in Senegal in 1998 to that in 2003?
Your response must be concise. 1.19. What is the ratio of the Aid flow (current US$) in Lithuania in 1998 to that in 2004?
Keep it short and to the point. 1.66. What is the ratio of the Aid flow (current US$) in Nigeria in 1998 to that in 2004?
Your answer should be compact. 0.41. What is the ratio of the Aid flow (current US$) of Senegal in 1998 to that in 2004?
Ensure brevity in your answer.  0.28. What is the ratio of the Aid flow (current US$) in Lithuania in 1999 to that in 2000?
Provide a succinct answer. 1.28. What is the ratio of the Aid flow (current US$) in Nigeria in 1999 to that in 2000?
Offer a terse response. 1.26. What is the ratio of the Aid flow (current US$) in Senegal in 1999 to that in 2000?
Give a very brief answer. 1.54. What is the ratio of the Aid flow (current US$) of Lithuania in 1999 to that in 2001?
Provide a succinct answer. 1.38. What is the ratio of the Aid flow (current US$) of Nigeria in 1999 to that in 2001?
Your answer should be very brief. 0.35. What is the ratio of the Aid flow (current US$) in Senegal in 1999 to that in 2001?
Your answer should be very brief. 2.21. What is the ratio of the Aid flow (current US$) in Lithuania in 1999 to that in 2002?
Offer a terse response. 0.91. What is the ratio of the Aid flow (current US$) in Nigeria in 1999 to that in 2002?
Provide a short and direct response. 0.59. What is the ratio of the Aid flow (current US$) of Senegal in 1999 to that in 2002?
Give a very brief answer. 2.17. What is the ratio of the Aid flow (current US$) of Lithuania in 1999 to that in 2003?
Provide a succinct answer. 0.69. What is the ratio of the Aid flow (current US$) of Nigeria in 1999 to that in 2003?
Your answer should be compact. 0.65. What is the ratio of the Aid flow (current US$) in Senegal in 1999 to that in 2003?
Provide a succinct answer. 1.89. What is the ratio of the Aid flow (current US$) in Lithuania in 1999 to that in 2004?
Make the answer very short. 0.49. What is the ratio of the Aid flow (current US$) of Nigeria in 1999 to that in 2004?
Your answer should be very brief. 0.7. What is the ratio of the Aid flow (current US$) of Senegal in 1999 to that in 2004?
Keep it short and to the point. 0.44. What is the ratio of the Aid flow (current US$) of Lithuania in 2000 to that in 2001?
Your answer should be very brief. 1.08. What is the ratio of the Aid flow (current US$) in Nigeria in 2000 to that in 2001?
Your answer should be compact. 0.28. What is the ratio of the Aid flow (current US$) in Senegal in 2000 to that in 2001?
Make the answer very short. 1.44. What is the ratio of the Aid flow (current US$) in Lithuania in 2000 to that in 2002?
Give a very brief answer. 0.71. What is the ratio of the Aid flow (current US$) of Nigeria in 2000 to that in 2002?
Provide a short and direct response. 0.47. What is the ratio of the Aid flow (current US$) of Senegal in 2000 to that in 2002?
Offer a very short reply. 1.41. What is the ratio of the Aid flow (current US$) of Lithuania in 2000 to that in 2003?
Your response must be concise. 0.54. What is the ratio of the Aid flow (current US$) of Nigeria in 2000 to that in 2003?
Provide a short and direct response. 0.51. What is the ratio of the Aid flow (current US$) of Senegal in 2000 to that in 2003?
Provide a short and direct response. 1.23. What is the ratio of the Aid flow (current US$) in Lithuania in 2000 to that in 2004?
Your response must be concise. 0.39. What is the ratio of the Aid flow (current US$) in Nigeria in 2000 to that in 2004?
Provide a succinct answer. 0.56. What is the ratio of the Aid flow (current US$) of Senegal in 2000 to that in 2004?
Your answer should be very brief. 0.29. What is the ratio of the Aid flow (current US$) of Lithuania in 2001 to that in 2002?
Your response must be concise. 0.66. What is the ratio of the Aid flow (current US$) in Nigeria in 2001 to that in 2002?
Your answer should be compact. 1.68. What is the ratio of the Aid flow (current US$) of Senegal in 2001 to that in 2002?
Your response must be concise. 0.98. What is the ratio of the Aid flow (current US$) in Lithuania in 2001 to that in 2003?
Offer a terse response. 0.5. What is the ratio of the Aid flow (current US$) in Nigeria in 2001 to that in 2003?
Ensure brevity in your answer.  1.85. What is the ratio of the Aid flow (current US$) of Senegal in 2001 to that in 2003?
Make the answer very short. 0.86. What is the ratio of the Aid flow (current US$) of Lithuania in 2001 to that in 2004?
Your answer should be very brief. 0.36. What is the ratio of the Aid flow (current US$) of Nigeria in 2001 to that in 2004?
Offer a terse response. 2.01. What is the ratio of the Aid flow (current US$) of Senegal in 2001 to that in 2004?
Your response must be concise. 0.2. What is the ratio of the Aid flow (current US$) in Lithuania in 2002 to that in 2003?
Ensure brevity in your answer.  0.76. What is the ratio of the Aid flow (current US$) in Nigeria in 2002 to that in 2003?
Offer a very short reply. 1.1. What is the ratio of the Aid flow (current US$) in Senegal in 2002 to that in 2003?
Your answer should be compact. 0.87. What is the ratio of the Aid flow (current US$) of Lithuania in 2002 to that in 2004?
Make the answer very short. 0.54. What is the ratio of the Aid flow (current US$) in Nigeria in 2002 to that in 2004?
Make the answer very short. 1.19. What is the ratio of the Aid flow (current US$) of Senegal in 2002 to that in 2004?
Your response must be concise. 0.2. What is the ratio of the Aid flow (current US$) of Lithuania in 2003 to that in 2004?
Your response must be concise. 0.71. What is the ratio of the Aid flow (current US$) in Nigeria in 2003 to that in 2004?
Your answer should be compact. 1.08. What is the ratio of the Aid flow (current US$) of Senegal in 2003 to that in 2004?
Keep it short and to the point. 0.23. What is the difference between the highest and the second highest Aid flow (current US$) in Lithuania?
Provide a succinct answer. 2.46e+06. What is the difference between the highest and the second highest Aid flow (current US$) of Nigeria?
Your answer should be compact. 6.02e+06. What is the difference between the highest and the second highest Aid flow (current US$) in Senegal?
Keep it short and to the point. 2.83e+08. What is the difference between the highest and the lowest Aid flow (current US$) in Dominica?
Ensure brevity in your answer.  1.50e+05. What is the difference between the highest and the lowest Aid flow (current US$) in Lithuania?
Offer a terse response. 4.91e+06. What is the difference between the highest and the lowest Aid flow (current US$) of Nigeria?
Your response must be concise. 1.18e+07. What is the difference between the highest and the lowest Aid flow (current US$) in Senegal?
Make the answer very short. 4.07e+08. 